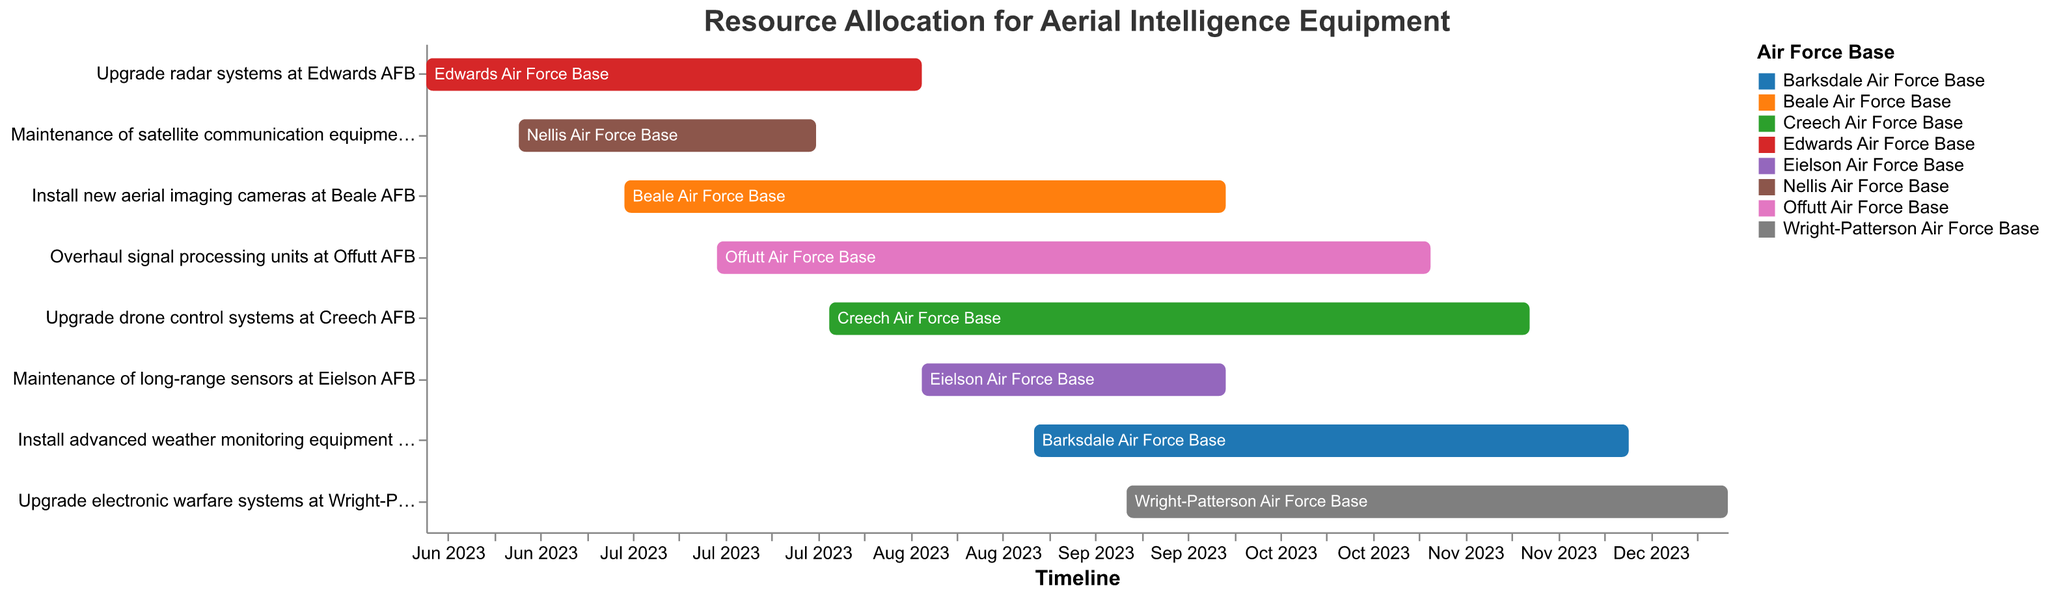When does the task "Upgrade radar systems at Edwards AFB" start and end? The task "Upgrade radar systems at Edwards AFB" starts on June 1, 2023, and ends on August 15, 2023, as indicated by the start and end date on the respective bar.
Answer: June 1, 2023 - August 15, 2023 How many tasks are scheduled to be completed by the end of September 2023? Visual inspection of the figure shows that tasks ending by September 30, 2023, are: "Upgrade radar systems at Edwards AFB," "Maintenance of satellite communication equipment at Nellis AFB," "Install new aerial imaging cameras at Beale AFB," and "Maintenance of long-range sensors at Eielson AFB."
Answer: 4 tasks Which base has the longest resource allocation task? Checking the durations of the bars in the Gantt chart, "Upgrade electronic warfare systems at Wright-Patterson AFB" spans from September 15, 2023, to December 15, 2023, which is the longest duration task.
Answer: Wright-Patterson AFB Are there any tasks that overlap in August 2023? Observing the chart, multiple tasks overlap in August 2023: "Upgrade radar systems at Edwards AFB," "Maintenance of satellite communication equipment at Nellis AFB," "Install new aerial imaging cameras at Beale AFB," "Overhaul signal processing units at Offutt AFB," "Upgrade drone control systems at Creech AFB," and "Maintenance of long-range sensors at Eielson AFB."
Answer: Yes, there are overlapping tasks What's the shortest task duration, and which task does it belong to? Calculate the duration for each task by counting the days between the start and end dates. "Maintenance of satellite communication equipment at Nellis AFB" runs from June 15, 2023, to July 30, 2023, providing the shortest duration of 45 days.
Answer: Maintenance of satellite communication equipment at Nellis AFB Which months have the highest number of ongoing tasks? Visual inspection shows that the number of overlapping bars is highest in August and September 2023. Calculate the number of ongoing tasks for each month in these intervals.
Answer: August and September 2023 Which task starts last in 2023? Inspecting the Gantt chart shows "Upgrade electronic warfare systems at Wright-Patterson AFB" starts on September 15, 2023, the latest start date among all tasks.
Answer: Upgrade electronic warfare systems at Wright-Patterson AFB How many tasks involve installation of new equipment? Identifying tasks that mention "install" in the Gantt chart: "Install new aerial imaging cameras at Beale AFB" and "Install advanced weather monitoring equipment at Barksdale AFB."
Answer: 2 tasks How long does the task "Install advanced weather monitoring equipment at Barksdale AFB" take? Calculate the task duration from September 1, 2023, to November 30, 2023: 3 months (September 1 to November 30 is exactly 3 months).
Answer: 3 months 